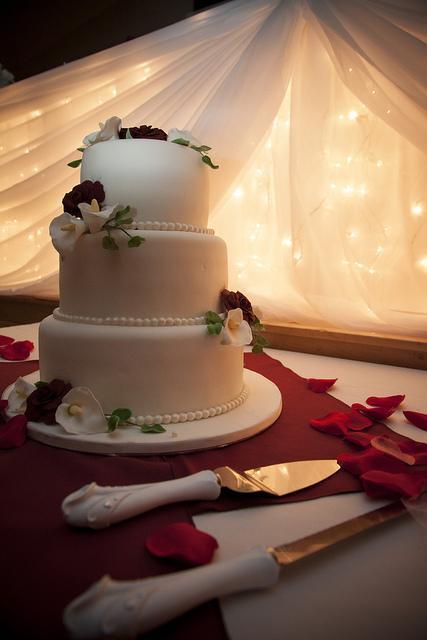How many utensils are in the table?
Give a very brief answer. 2. How many knives are in the photo?
Give a very brief answer. 2. 